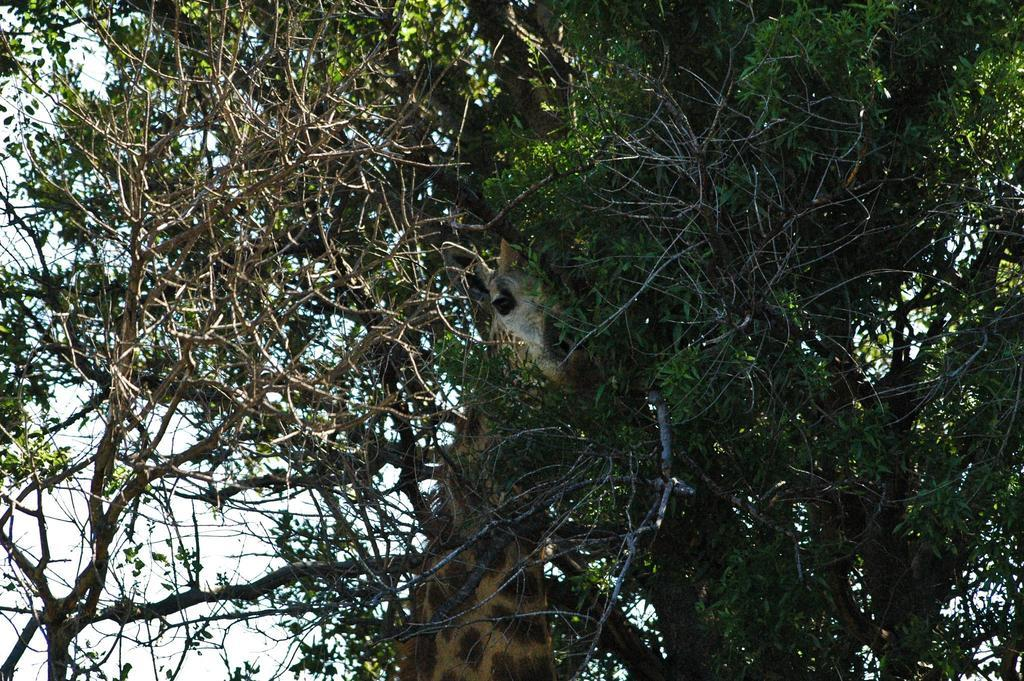What animal is the main subject of the image? There is a giraffe in the image. What is the giraffe's position in relation to the creepers? The giraffe is between creepers. What can be seen in the background of the image? There is sky visible in the background of the image. Can you describe the fight between the giraffe and the father in the image? There is no fight or father present in the image; it features a giraffe between creepers with sky visible in the background. 